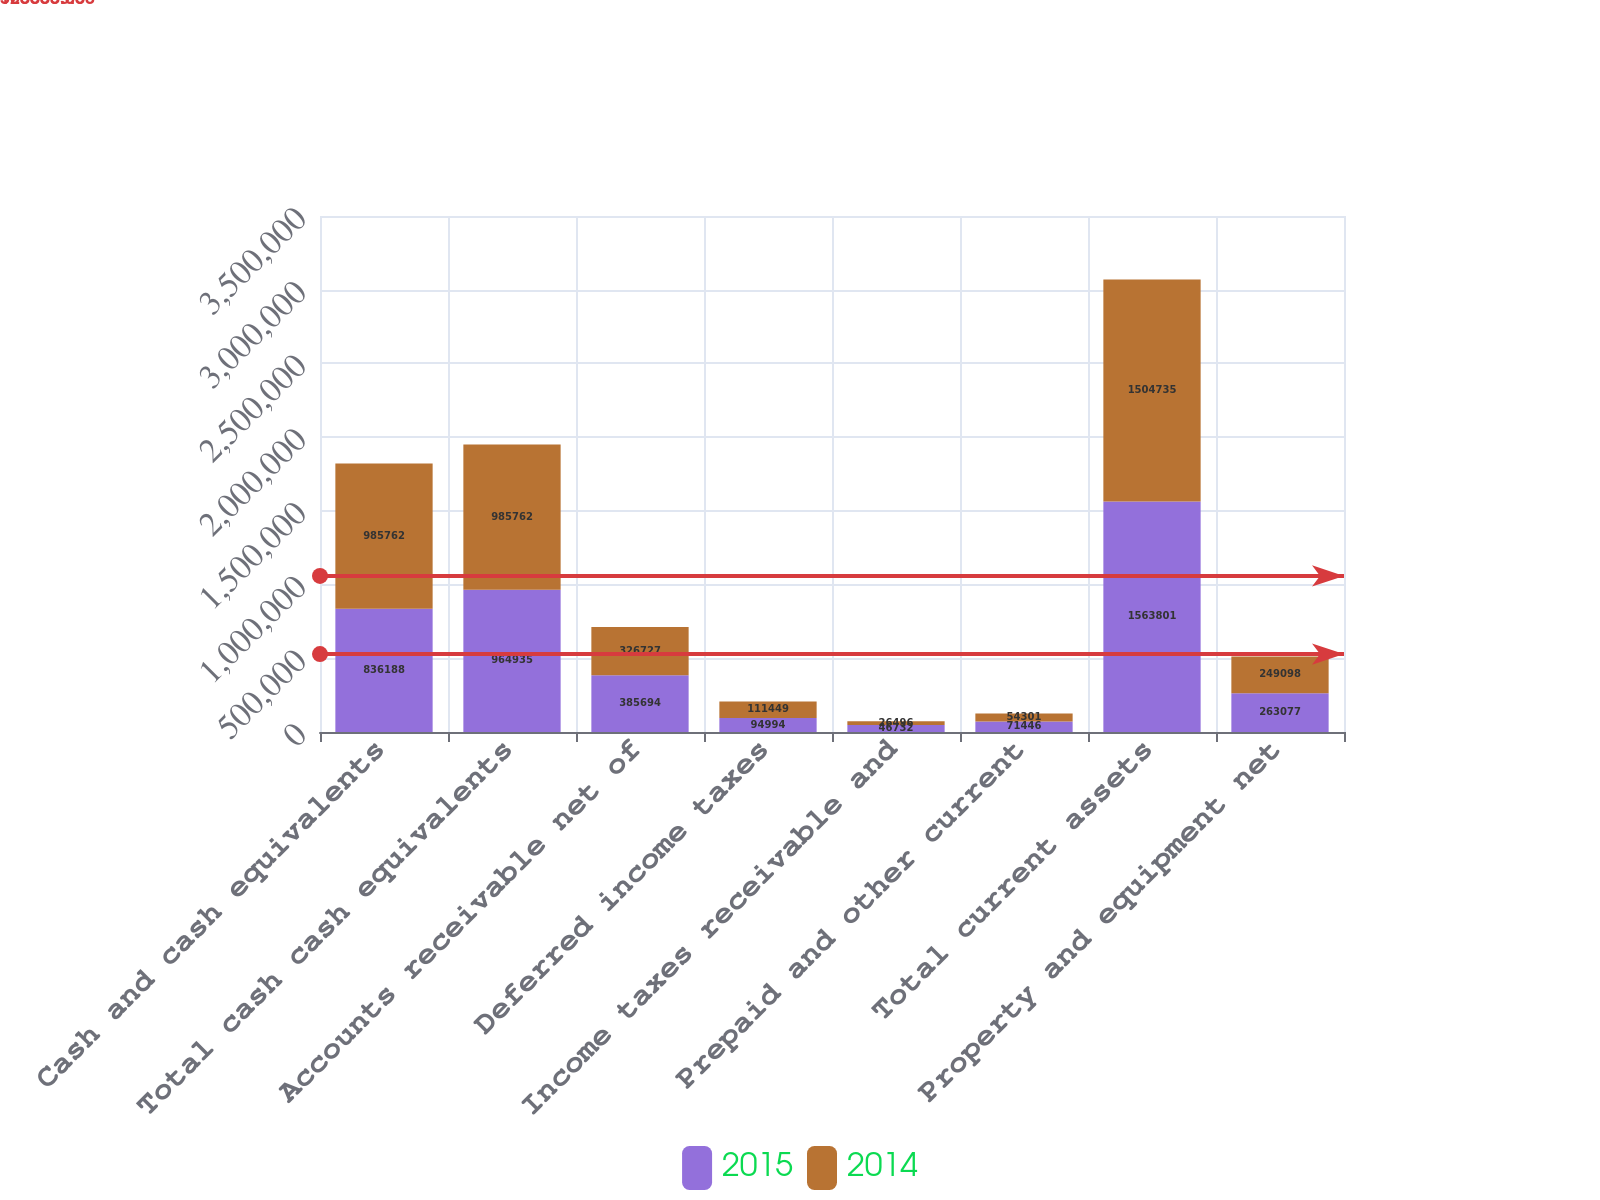Convert chart to OTSL. <chart><loc_0><loc_0><loc_500><loc_500><stacked_bar_chart><ecel><fcel>Cash and cash equivalents<fcel>Total cash cash equivalents<fcel>Accounts receivable net of<fcel>Deferred income taxes<fcel>Income taxes receivable and<fcel>Prepaid and other current<fcel>Total current assets<fcel>Property and equipment net<nl><fcel>2015<fcel>836188<fcel>964935<fcel>385694<fcel>94994<fcel>46732<fcel>71446<fcel>1.5638e+06<fcel>263077<nl><fcel>2014<fcel>985762<fcel>985762<fcel>326727<fcel>111449<fcel>26496<fcel>54301<fcel>1.50474e+06<fcel>249098<nl></chart> 